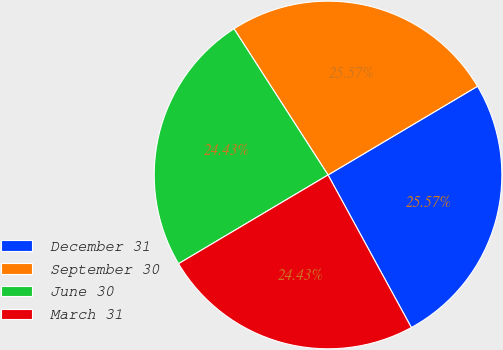Convert chart to OTSL. <chart><loc_0><loc_0><loc_500><loc_500><pie_chart><fcel>December 31<fcel>September 30<fcel>June 30<fcel>March 31<nl><fcel>25.57%<fcel>25.57%<fcel>24.43%<fcel>24.43%<nl></chart> 